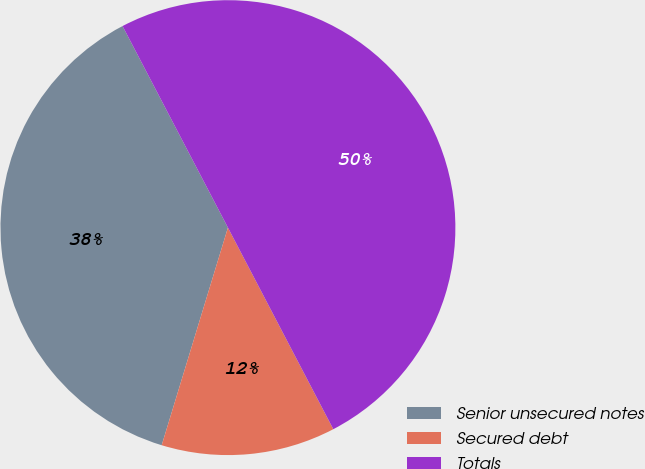Convert chart. <chart><loc_0><loc_0><loc_500><loc_500><pie_chart><fcel>Senior unsecured notes<fcel>Secured debt<fcel>Totals<nl><fcel>37.63%<fcel>12.37%<fcel>50.0%<nl></chart> 